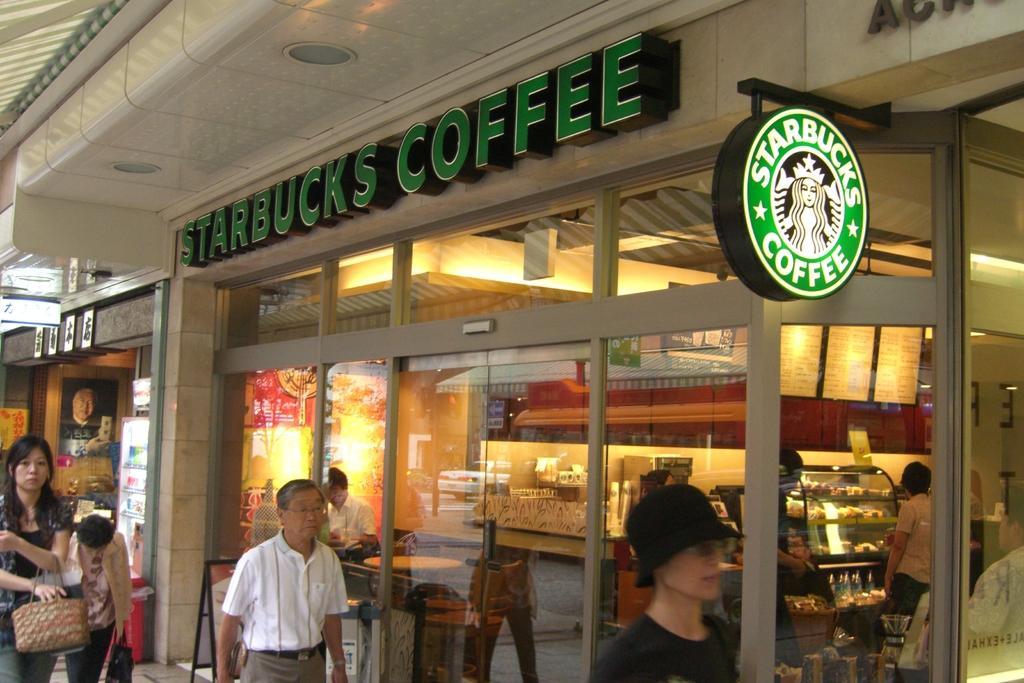Could you give a brief overview of what you see in this image? In this image we can see the buildings. On the buildings we can see the text and a board with text. We can see store in the buildings. In the store we can see group of food items and there are few persons inside the stores. We can see the glasses to the building. On the left side, we can see posters with text. There are few persons in front of the stores. 